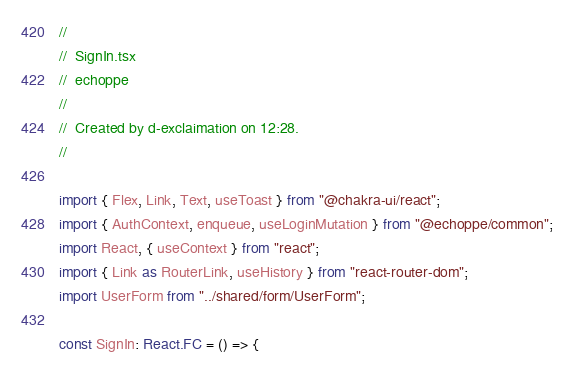Convert code to text. <code><loc_0><loc_0><loc_500><loc_500><_TypeScript_>//
//  SignIn.tsx
//  echoppe
//
//  Created by d-exclaimation on 12:28.
//

import { Flex, Link, Text, useToast } from "@chakra-ui/react";
import { AuthContext, enqueue, useLoginMutation } from "@echoppe/common";
import React, { useContext } from "react";
import { Link as RouterLink, useHistory } from "react-router-dom";
import UserForm from "../shared/form/UserForm";

const SignIn: React.FC = () => {</code> 